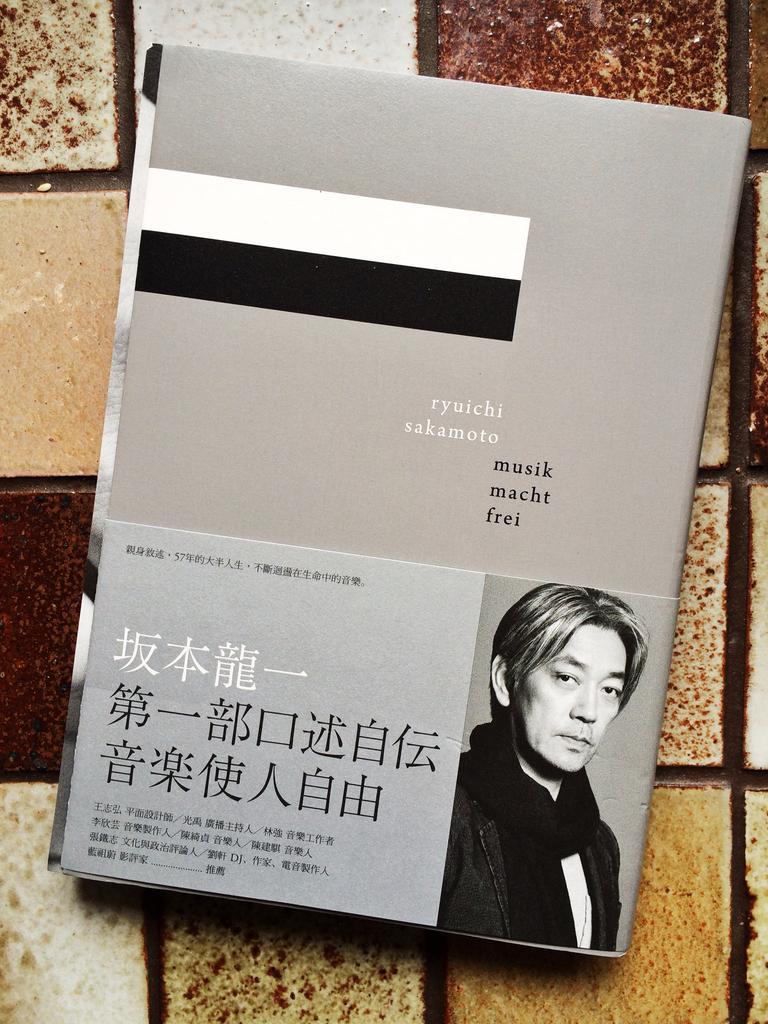How would you summarize this image in a sentence or two? In this image, we can see a book on the floor. 